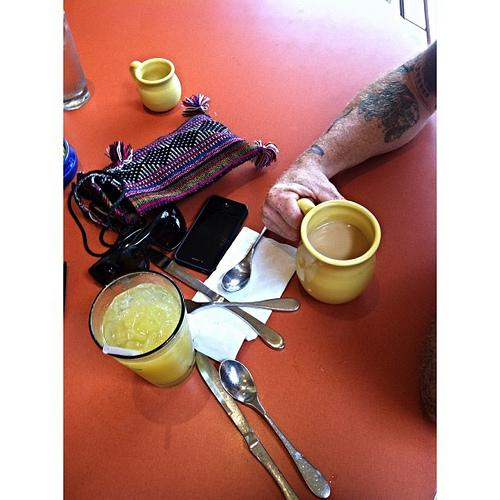Question: how many yellow cups are in this image?
Choices:
A. 1.
B. 3.
C. 4.
D. 2.
Answer with the letter. Answer: D Question: where is the yellow beverage in this image?
Choices:
A. Under a table.
B. Left side.
C. In the sky.
D. In my hand.
Answer with the letter. Answer: B Question: what does the arm in this photo have on it?
Choices:
A. A scratch.
B. A sleeve.
C. Tattoos.
D. A watch.
Answer with the letter. Answer: C Question: how is the hand holding the cup?
Choices:
A. With ease.
B. With fingers.
C. Carefully.
D. By the handle.
Answer with the letter. Answer: D Question: what is the object to the left of the phone and above the yellow beverage?
Choices:
A. The sun.
B. Clouds.
C. A lamp.
D. Sunglasses.
Answer with the letter. Answer: D Question: what is the white item in this photo?
Choices:
A. A tablecloth.
B. A candle.
C. My shirt.
D. Napkin.
Answer with the letter. Answer: D 